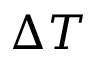Convert formula to latex. <formula><loc_0><loc_0><loc_500><loc_500>\Delta T</formula> 